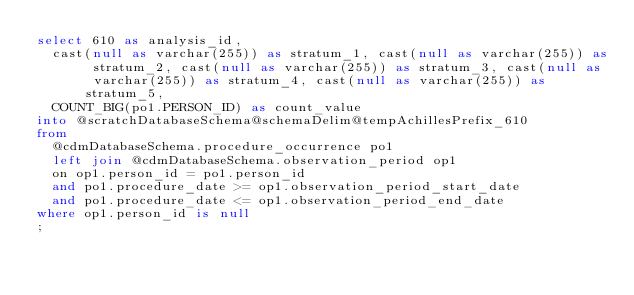<code> <loc_0><loc_0><loc_500><loc_500><_SQL_>select 610 as analysis_id,  
	cast(null as varchar(255)) as stratum_1, cast(null as varchar(255)) as stratum_2, cast(null as varchar(255)) as stratum_3, cast(null as varchar(255)) as stratum_4, cast(null as varchar(255)) as stratum_5,
	COUNT_BIG(po1.PERSON_ID) as count_value
into @scratchDatabaseSchema@schemaDelim@tempAchillesPrefix_610
from
	@cdmDatabaseSchema.procedure_occurrence po1
	left join @cdmDatabaseSchema.observation_period op1
	on op1.person_id = po1.person_id
	and po1.procedure_date >= op1.observation_period_start_date
	and po1.procedure_date <= op1.observation_period_end_date
where op1.person_id is null
;
</code> 